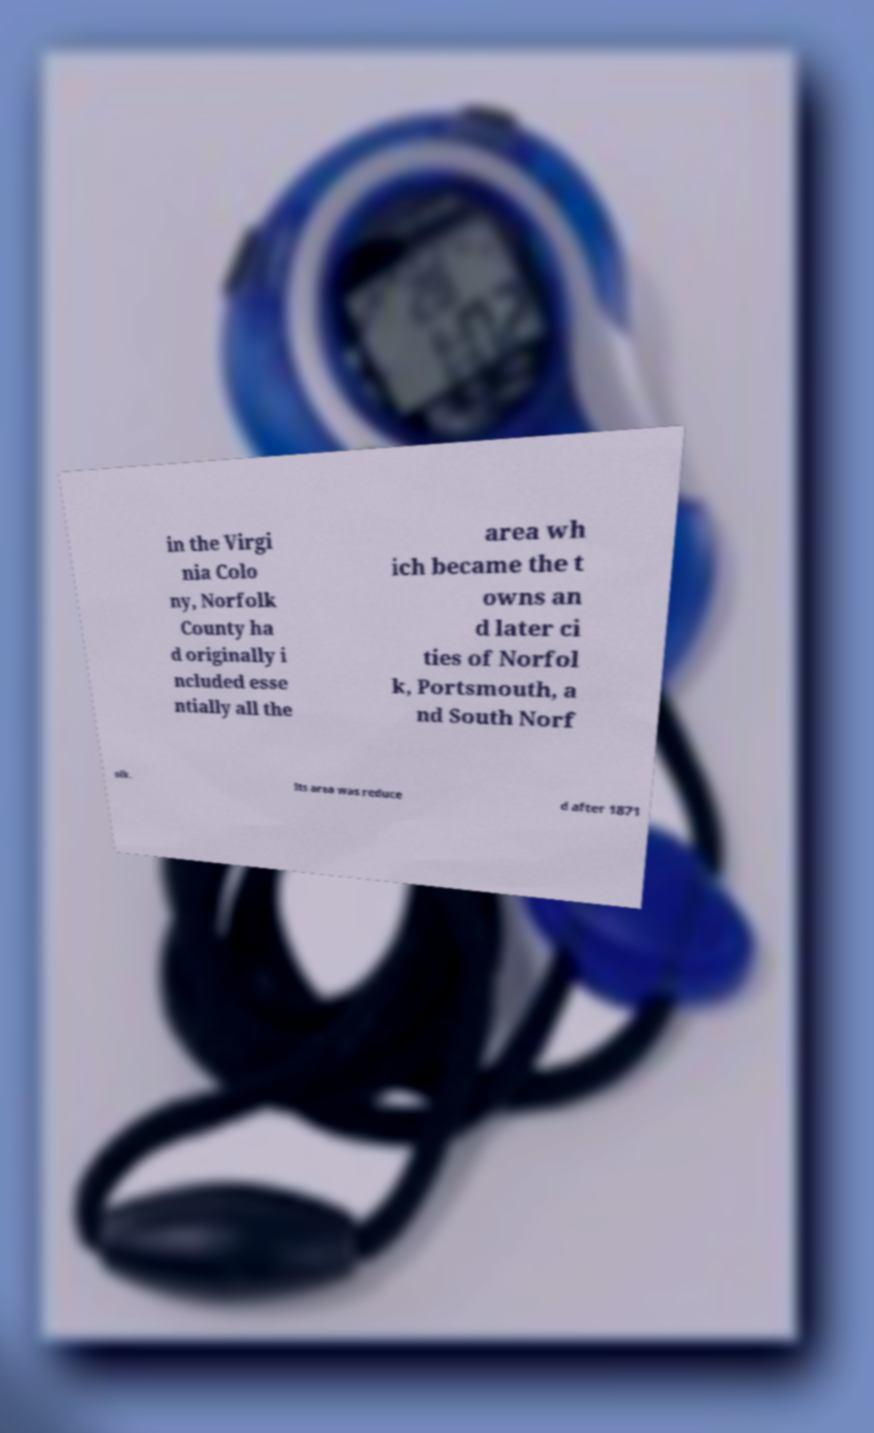Please identify and transcribe the text found in this image. in the Virgi nia Colo ny, Norfolk County ha d originally i ncluded esse ntially all the area wh ich became the t owns an d later ci ties of Norfol k, Portsmouth, a nd South Norf olk. Its area was reduce d after 1871 